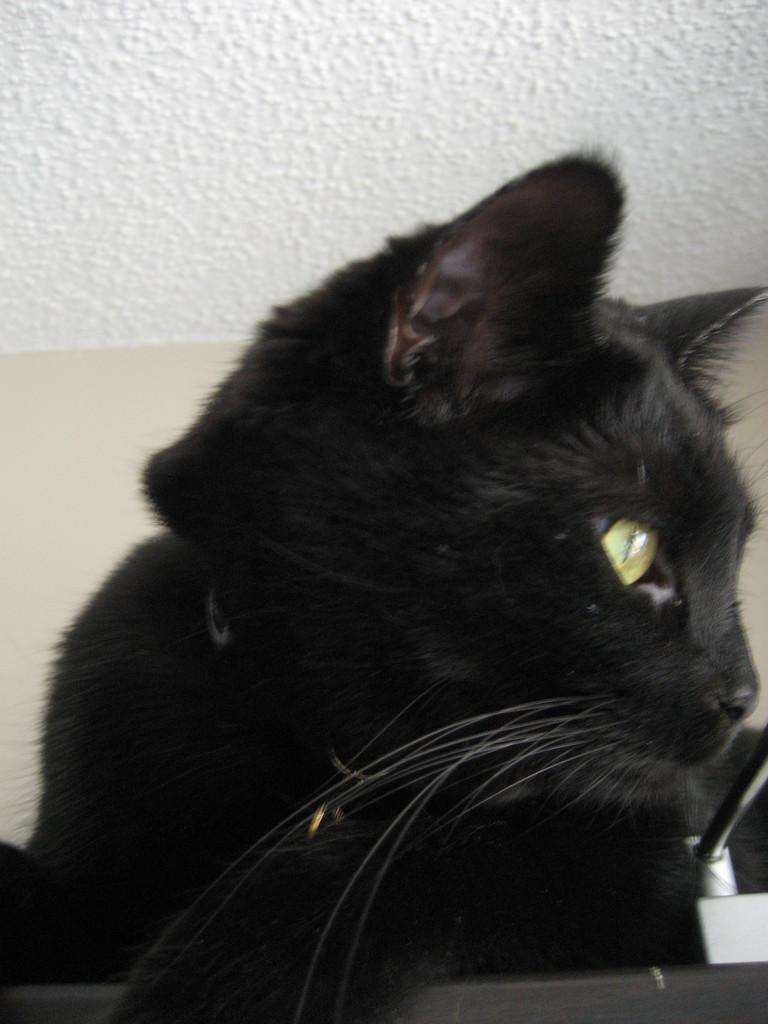What type of animal is in the image? There is a black cat in the image. What is the primary background element in the image? There is a wall in the image. What arithmetic problem is the cat solving in the image? There is no arithmetic problem present in the image; it features a black cat and a wall. How many hands does the cat have in the image? Cats, including the black cat in the image, do not have hands. --- 